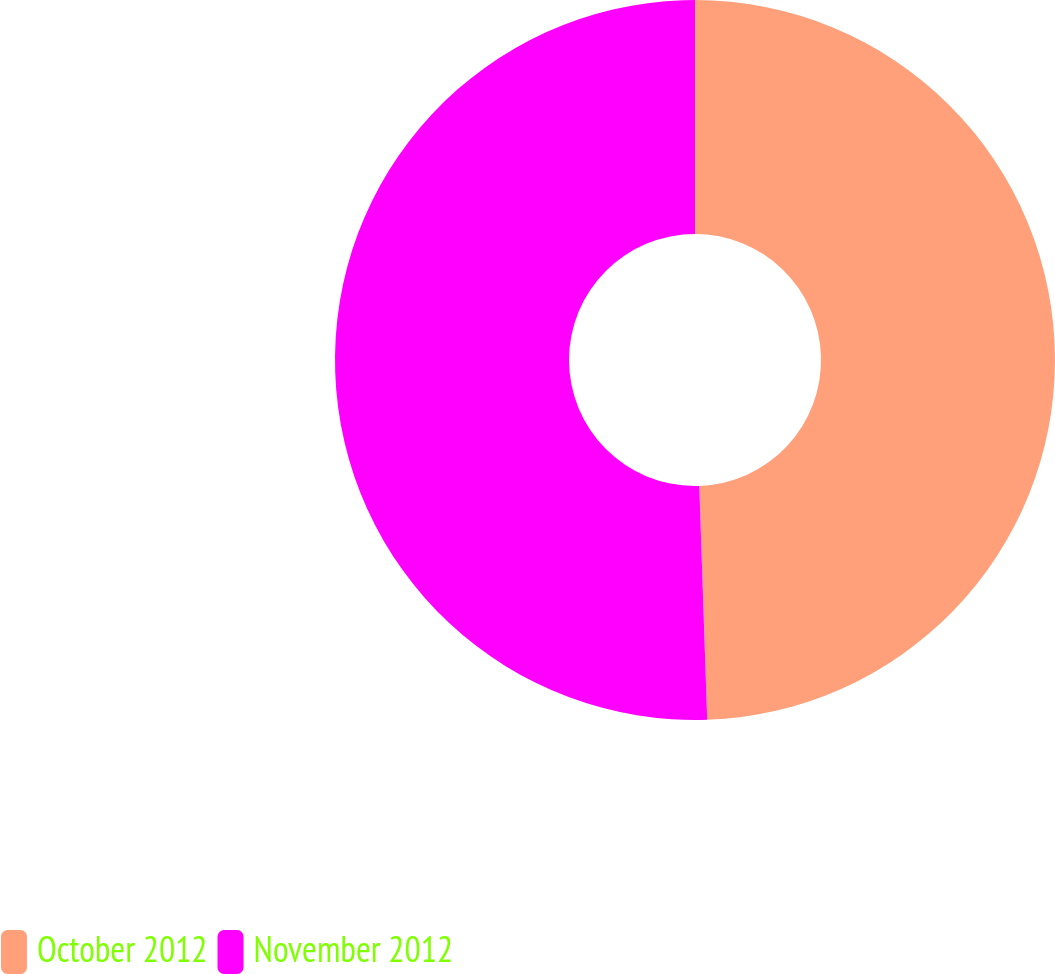Convert chart to OTSL. <chart><loc_0><loc_0><loc_500><loc_500><pie_chart><fcel>October 2012<fcel>November 2012<nl><fcel>49.46%<fcel>50.54%<nl></chart> 